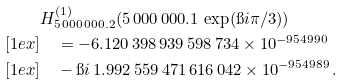<formula> <loc_0><loc_0><loc_500><loc_500>& H ^ { ( 1 ) } _ { 5 \, 0 0 0 \, 0 0 0 . 2 } ( 5 \, 0 0 0 \, 0 0 0 . 1 \, \exp ( \i i \pi / 3 ) ) \\ [ 1 e x ] & \quad = - 6 . 1 2 0 \, 3 9 8 \, 9 3 9 \, 5 9 8 \, 7 3 4 \times 1 0 ^ { - 9 5 4 9 9 0 } \\ [ 1 e x ] & \quad - \i i \, 1 . 9 9 2 \, 5 5 9 \, 4 7 1 \, 6 1 6 \, 0 4 2 \times 1 0 ^ { - 9 5 4 9 8 9 } \, .</formula> 